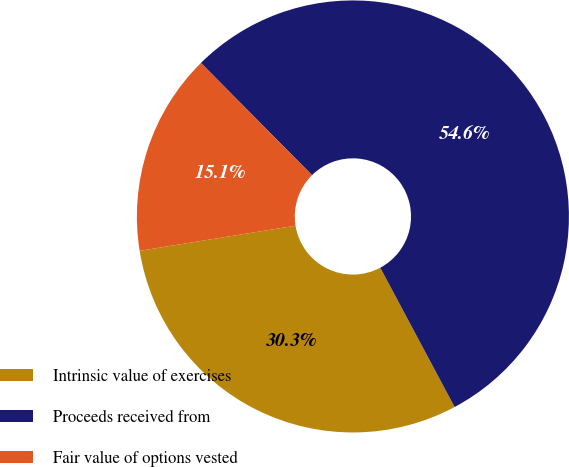Convert chart. <chart><loc_0><loc_0><loc_500><loc_500><pie_chart><fcel>Intrinsic value of exercises<fcel>Proceeds received from<fcel>Fair value of options vested<nl><fcel>30.26%<fcel>54.62%<fcel>15.12%<nl></chart> 